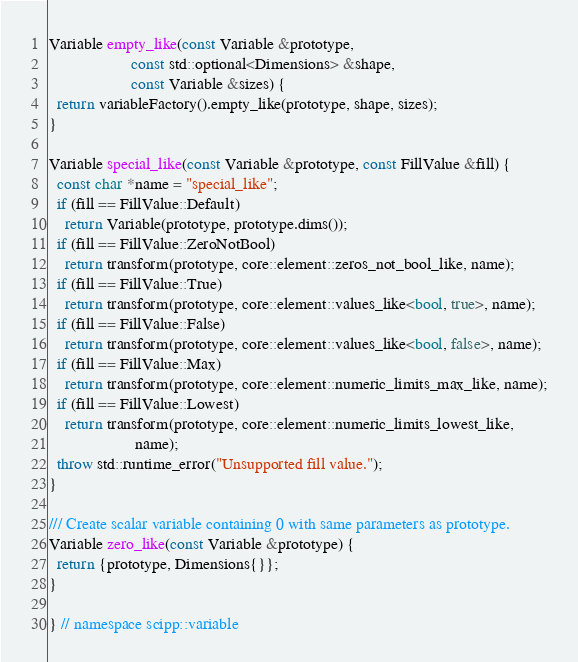Convert code to text. <code><loc_0><loc_0><loc_500><loc_500><_C++_>Variable empty_like(const Variable &prototype,
                    const std::optional<Dimensions> &shape,
                    const Variable &sizes) {
  return variableFactory().empty_like(prototype, shape, sizes);
}

Variable special_like(const Variable &prototype, const FillValue &fill) {
  const char *name = "special_like";
  if (fill == FillValue::Default)
    return Variable(prototype, prototype.dims());
  if (fill == FillValue::ZeroNotBool)
    return transform(prototype, core::element::zeros_not_bool_like, name);
  if (fill == FillValue::True)
    return transform(prototype, core::element::values_like<bool, true>, name);
  if (fill == FillValue::False)
    return transform(prototype, core::element::values_like<bool, false>, name);
  if (fill == FillValue::Max)
    return transform(prototype, core::element::numeric_limits_max_like, name);
  if (fill == FillValue::Lowest)
    return transform(prototype, core::element::numeric_limits_lowest_like,
                     name);
  throw std::runtime_error("Unsupported fill value.");
}

/// Create scalar variable containing 0 with same parameters as prototype.
Variable zero_like(const Variable &prototype) {
  return {prototype, Dimensions{}};
}

} // namespace scipp::variable
</code> 